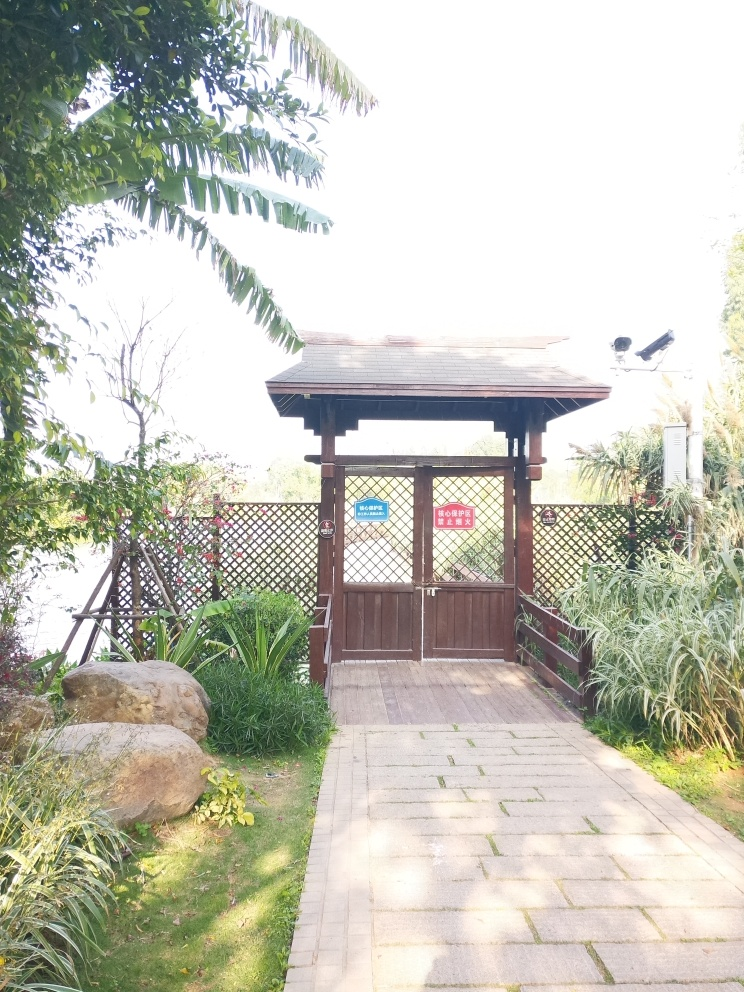What time of day does this image appear to have been taken? The shadows are soft and the lighting suggests it is not the peak of daylight, likely indicating that the photo was taken either in the morning or late afternoon. The peaceful and well-maintained appearance of the garden pavilion hints at a serene start or end to the day. 